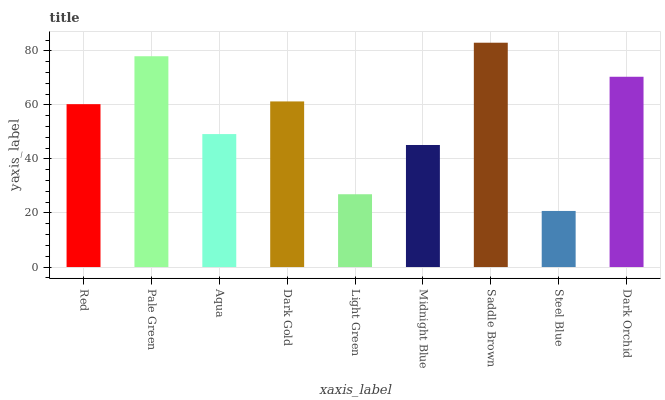Is Pale Green the minimum?
Answer yes or no. No. Is Pale Green the maximum?
Answer yes or no. No. Is Pale Green greater than Red?
Answer yes or no. Yes. Is Red less than Pale Green?
Answer yes or no. Yes. Is Red greater than Pale Green?
Answer yes or no. No. Is Pale Green less than Red?
Answer yes or no. No. Is Red the high median?
Answer yes or no. Yes. Is Red the low median?
Answer yes or no. Yes. Is Dark Gold the high median?
Answer yes or no. No. Is Light Green the low median?
Answer yes or no. No. 